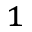<formula> <loc_0><loc_0><loc_500><loc_500>_ { 1 }</formula> 